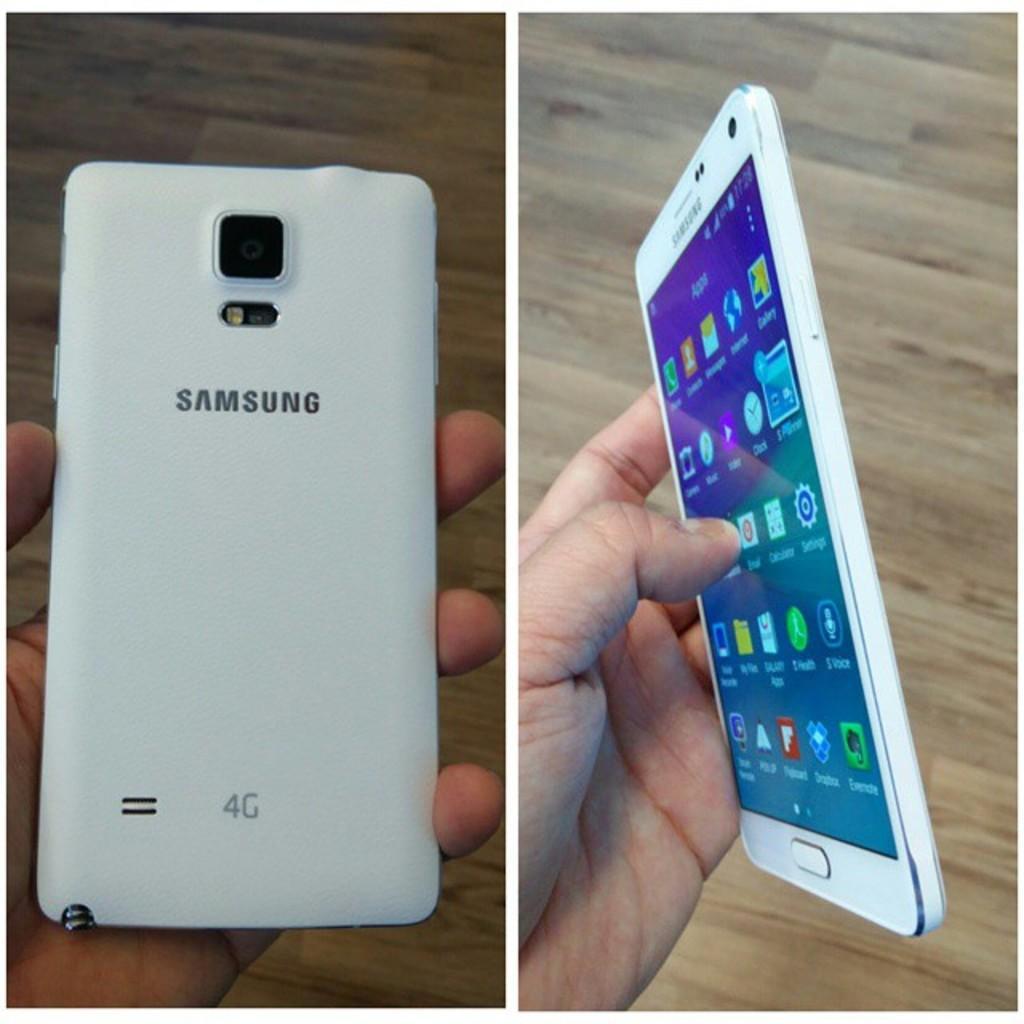How would you summarize this image in a sentence or two? This is a collage image. There are two pictures. In both the images I can see a person's hand holding a mobile. On the mobile which is on the right side, I can see some applications on the screen. 